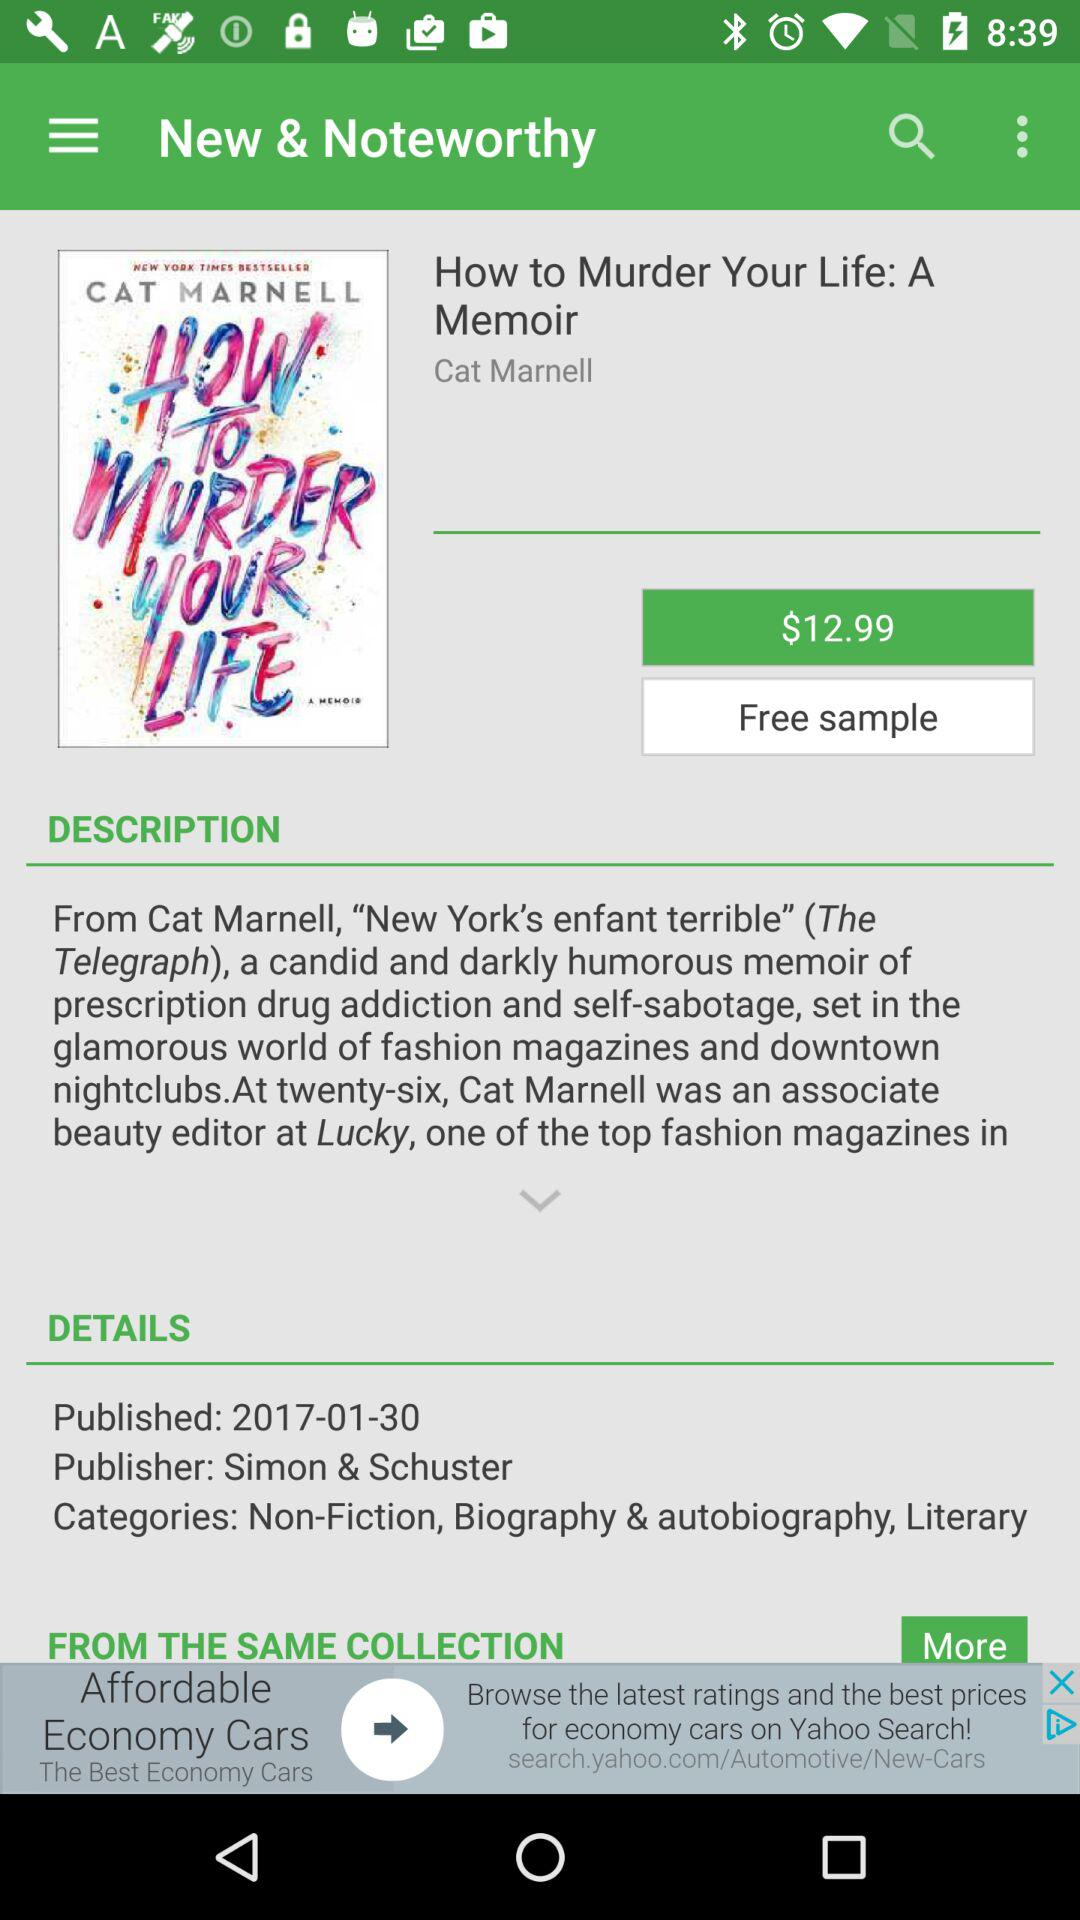How much more expensive is the book than the free sample?
Answer the question using a single word or phrase. $12.99 